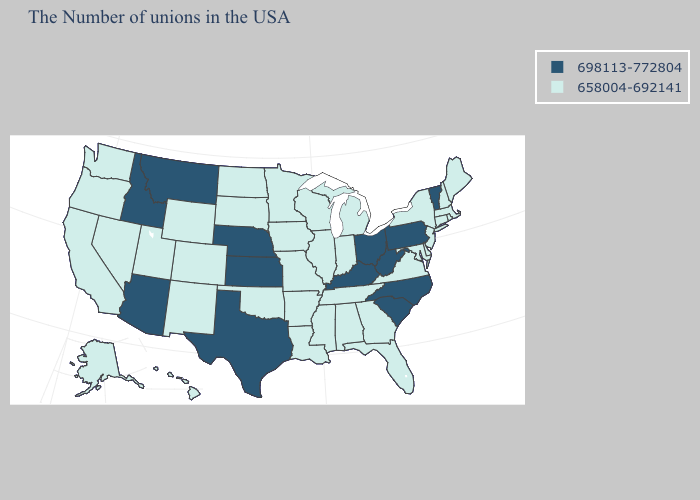Name the states that have a value in the range 698113-772804?
Answer briefly. Vermont, Pennsylvania, North Carolina, South Carolina, West Virginia, Ohio, Kentucky, Kansas, Nebraska, Texas, Montana, Arizona, Idaho. Name the states that have a value in the range 658004-692141?
Answer briefly. Maine, Massachusetts, Rhode Island, New Hampshire, Connecticut, New York, New Jersey, Delaware, Maryland, Virginia, Florida, Georgia, Michigan, Indiana, Alabama, Tennessee, Wisconsin, Illinois, Mississippi, Louisiana, Missouri, Arkansas, Minnesota, Iowa, Oklahoma, South Dakota, North Dakota, Wyoming, Colorado, New Mexico, Utah, Nevada, California, Washington, Oregon, Alaska, Hawaii. Among the states that border Idaho , which have the lowest value?
Short answer required. Wyoming, Utah, Nevada, Washington, Oregon. Name the states that have a value in the range 658004-692141?
Concise answer only. Maine, Massachusetts, Rhode Island, New Hampshire, Connecticut, New York, New Jersey, Delaware, Maryland, Virginia, Florida, Georgia, Michigan, Indiana, Alabama, Tennessee, Wisconsin, Illinois, Mississippi, Louisiana, Missouri, Arkansas, Minnesota, Iowa, Oklahoma, South Dakota, North Dakota, Wyoming, Colorado, New Mexico, Utah, Nevada, California, Washington, Oregon, Alaska, Hawaii. Name the states that have a value in the range 658004-692141?
Concise answer only. Maine, Massachusetts, Rhode Island, New Hampshire, Connecticut, New York, New Jersey, Delaware, Maryland, Virginia, Florida, Georgia, Michigan, Indiana, Alabama, Tennessee, Wisconsin, Illinois, Mississippi, Louisiana, Missouri, Arkansas, Minnesota, Iowa, Oklahoma, South Dakota, North Dakota, Wyoming, Colorado, New Mexico, Utah, Nevada, California, Washington, Oregon, Alaska, Hawaii. Name the states that have a value in the range 698113-772804?
Be succinct. Vermont, Pennsylvania, North Carolina, South Carolina, West Virginia, Ohio, Kentucky, Kansas, Nebraska, Texas, Montana, Arizona, Idaho. Which states have the lowest value in the South?
Be succinct. Delaware, Maryland, Virginia, Florida, Georgia, Alabama, Tennessee, Mississippi, Louisiana, Arkansas, Oklahoma. Does New York have a higher value than Nebraska?
Write a very short answer. No. Among the states that border Vermont , which have the lowest value?
Be succinct. Massachusetts, New Hampshire, New York. Does Massachusetts have the lowest value in the USA?
Concise answer only. Yes. What is the value of Hawaii?
Concise answer only. 658004-692141. Name the states that have a value in the range 698113-772804?
Answer briefly. Vermont, Pennsylvania, North Carolina, South Carolina, West Virginia, Ohio, Kentucky, Kansas, Nebraska, Texas, Montana, Arizona, Idaho. What is the value of Wisconsin?
Quick response, please. 658004-692141. What is the value of Colorado?
Give a very brief answer. 658004-692141. Name the states that have a value in the range 698113-772804?
Concise answer only. Vermont, Pennsylvania, North Carolina, South Carolina, West Virginia, Ohio, Kentucky, Kansas, Nebraska, Texas, Montana, Arizona, Idaho. 